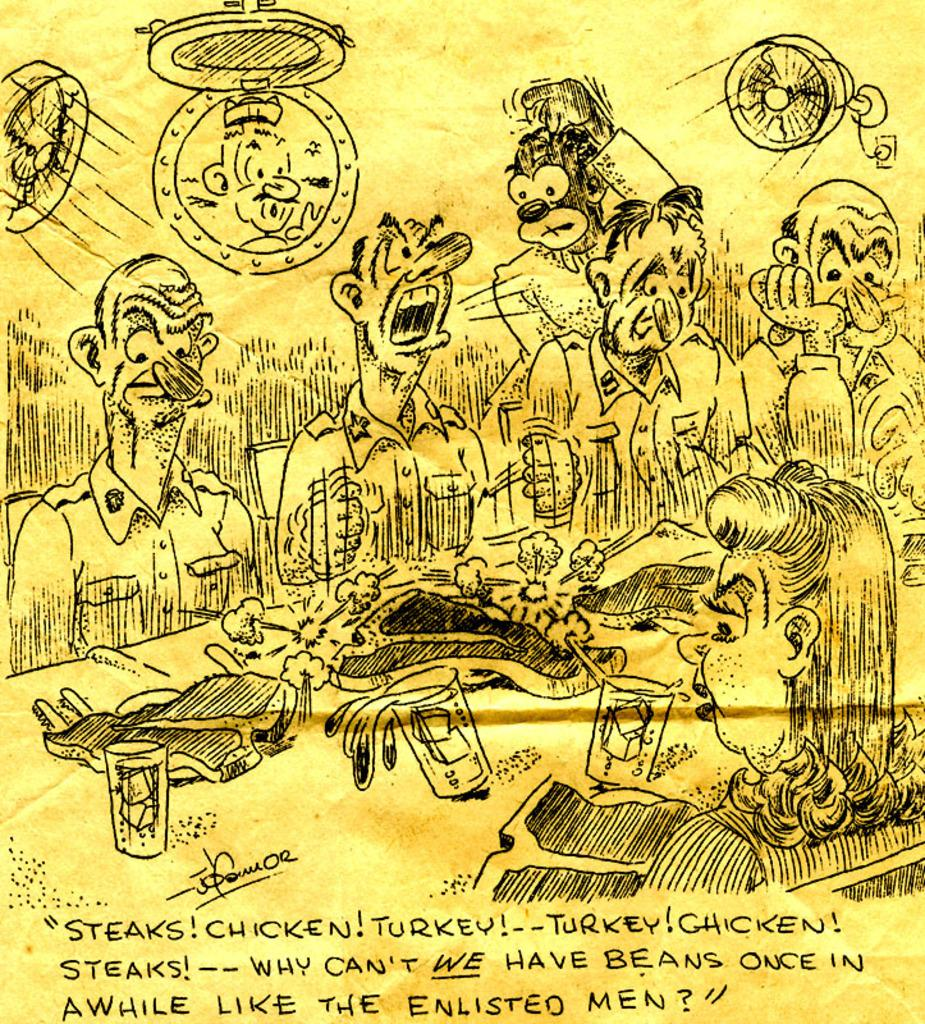What type of images are present in the image? There are cartoon images in the image. What else can be seen in the image besides the cartoon images? There is text on a paper in the image. What type of crown is worn by the cartoon character in the image? There is no crown present in the image; it only features cartoon images and text on a paper. 